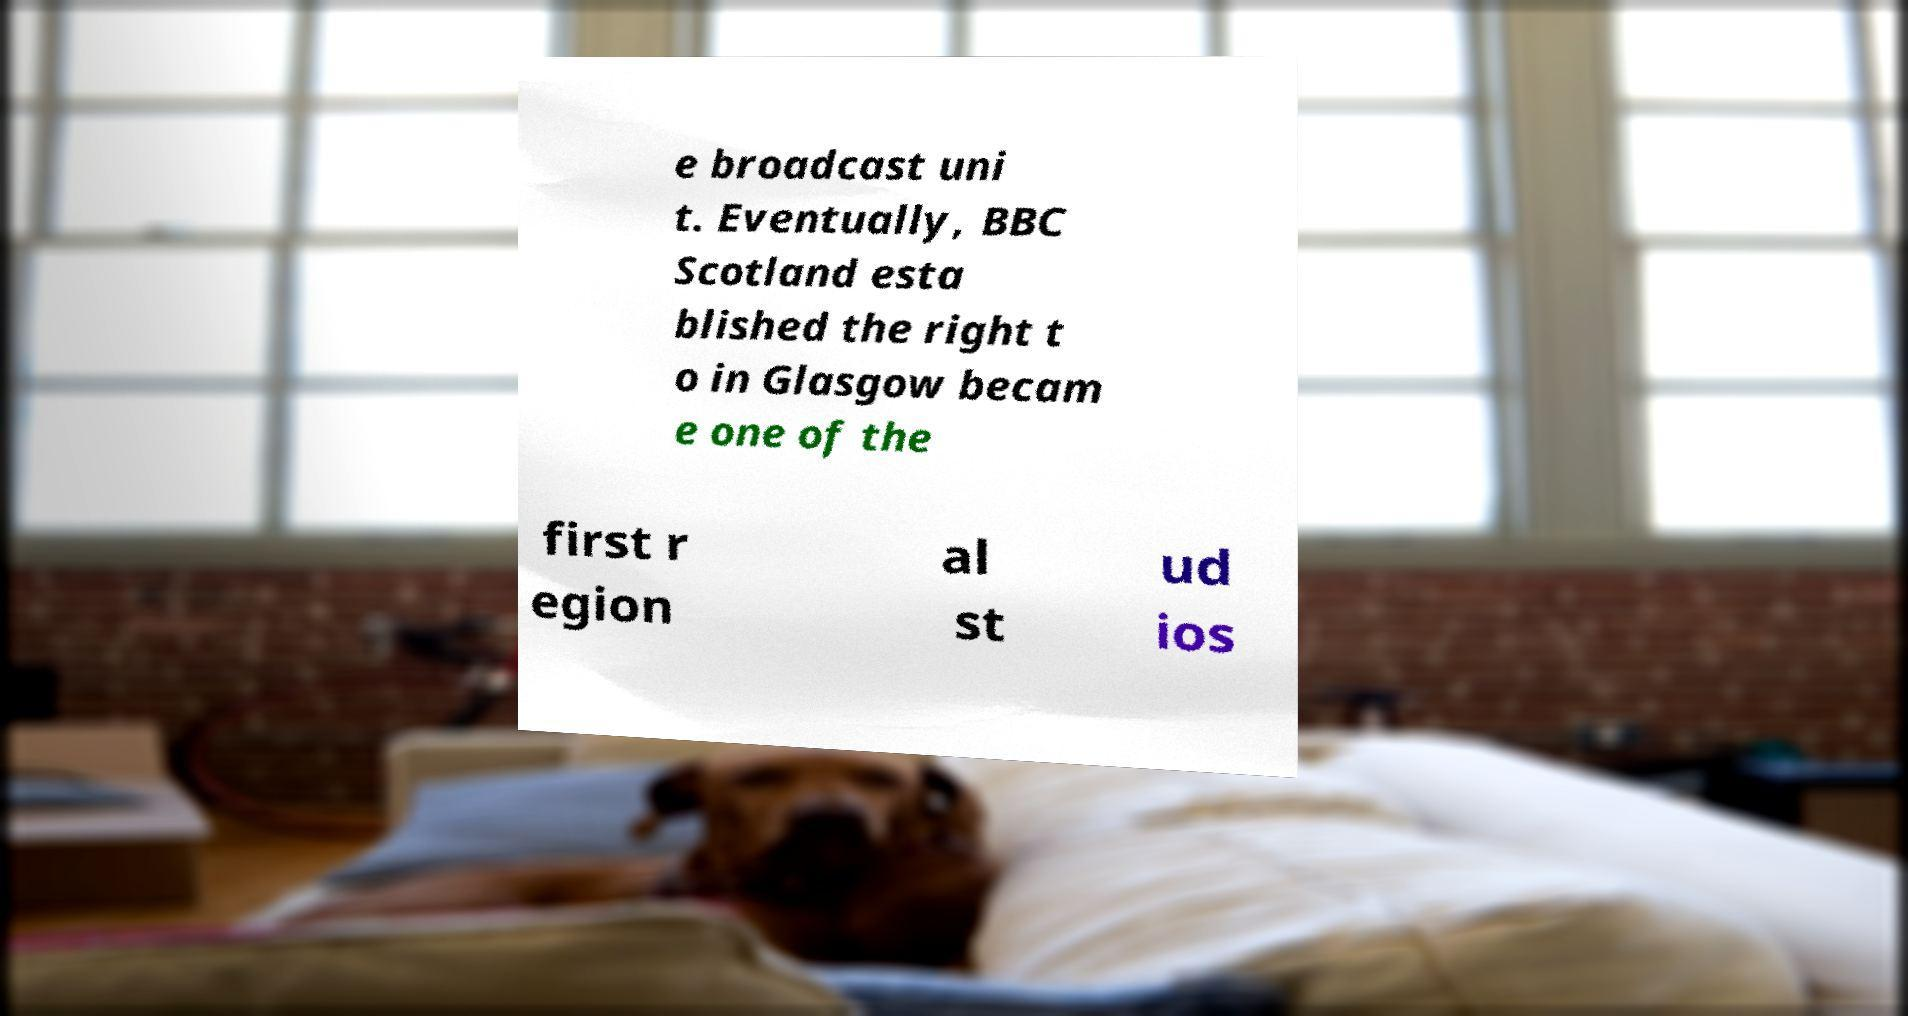Can you accurately transcribe the text from the provided image for me? e broadcast uni t. Eventually, BBC Scotland esta blished the right t o in Glasgow becam e one of the first r egion al st ud ios 